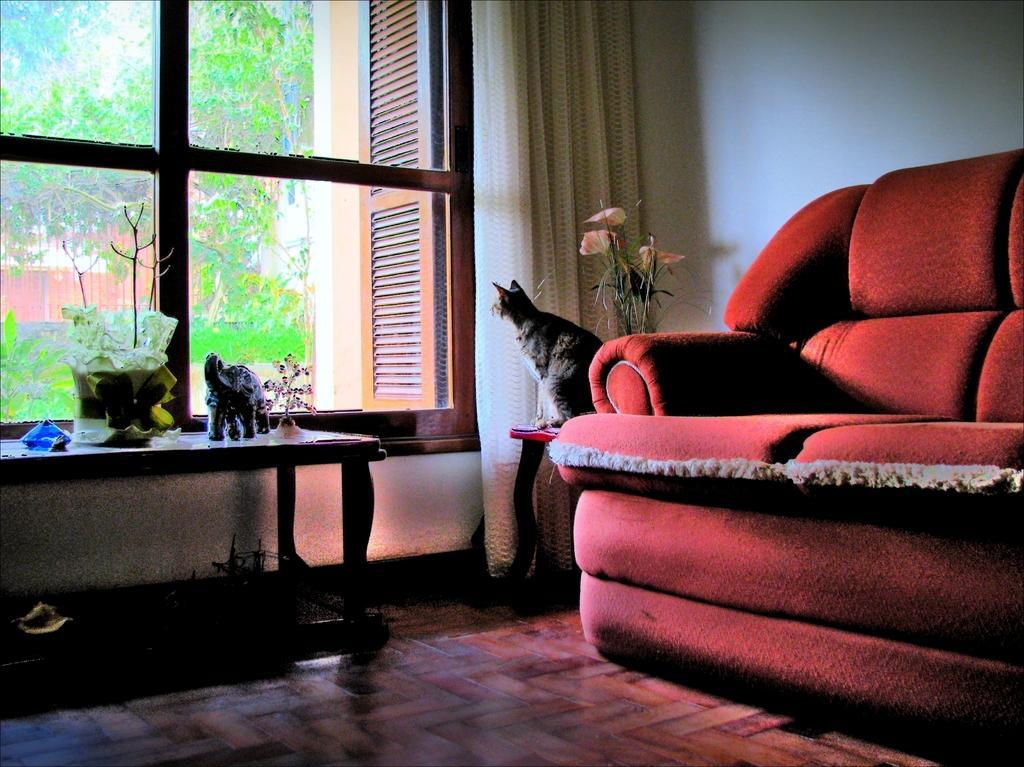Could you give a brief overview of what you see in this image? In this image i can see a couch a cat sitting on a table, there is a small flower pot at right there is a toy elephant, a flower pot on a table at the back ground i can see a curtain, a wall, a window and a tree. 